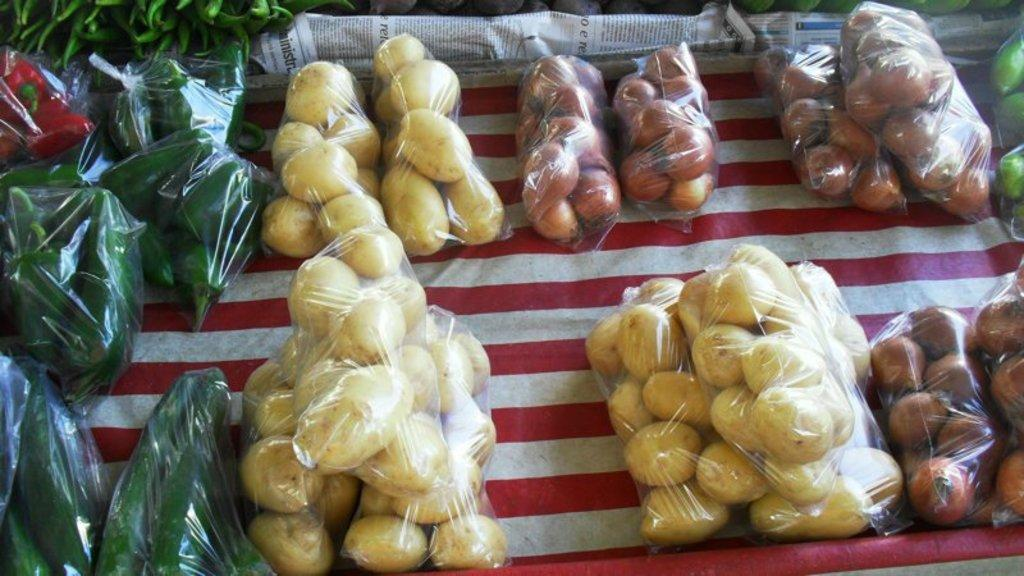What types of food items are visible in the image? There are different types of vegetables in the image. How are the vegetables packaged? The vegetables are packed in plastic covers. What is the color of the cloth on which the vegetables are placed? The vegetables are placed on a red and white color cloth. What type of thread is used to sew the vegetables together in the image? There is no thread or sewing involved in the image; the vegetables are packaged in plastic covers. 